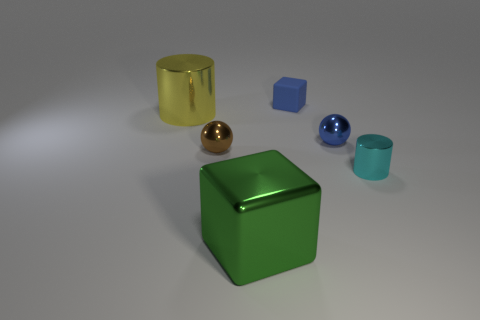Add 4 tiny blue cubes. How many objects exist? 10 Subtract all cylinders. How many objects are left? 4 Subtract all yellow cylinders. Subtract all yellow cylinders. How many objects are left? 4 Add 5 large blocks. How many large blocks are left? 6 Add 3 tiny purple matte cylinders. How many tiny purple matte cylinders exist? 3 Subtract 0 purple spheres. How many objects are left? 6 